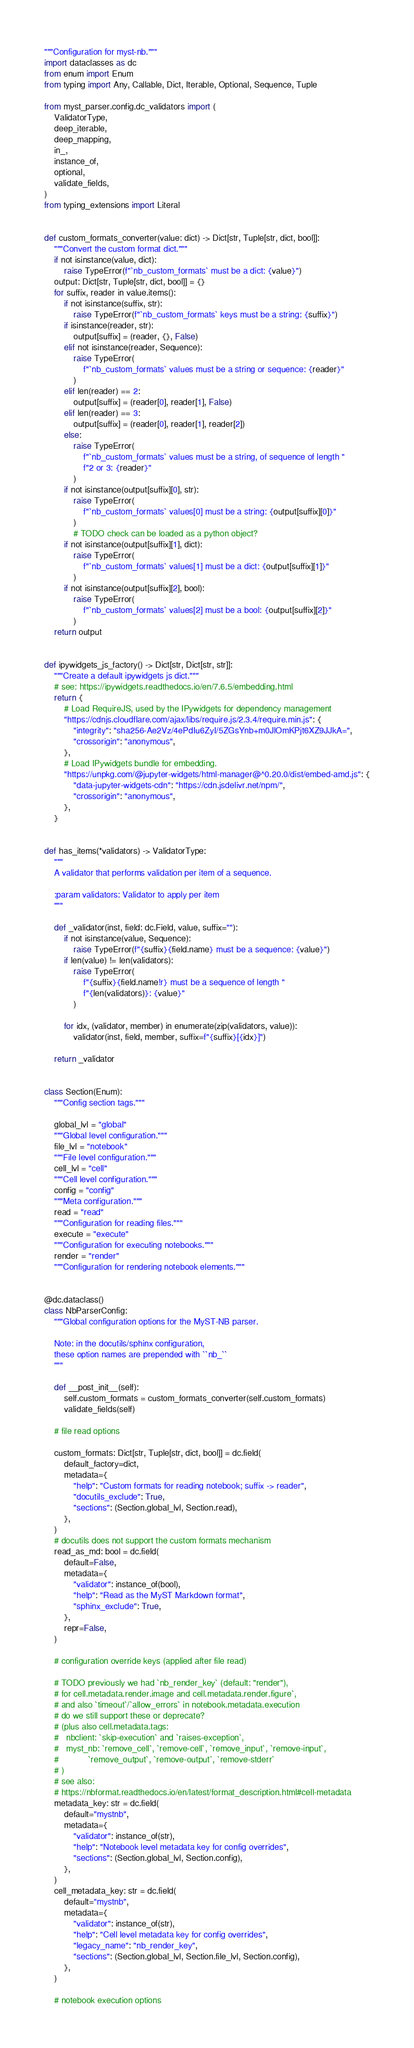Convert code to text. <code><loc_0><loc_0><loc_500><loc_500><_Python_>"""Configuration for myst-nb."""
import dataclasses as dc
from enum import Enum
from typing import Any, Callable, Dict, Iterable, Optional, Sequence, Tuple

from myst_parser.config.dc_validators import (
    ValidatorType,
    deep_iterable,
    deep_mapping,
    in_,
    instance_of,
    optional,
    validate_fields,
)
from typing_extensions import Literal


def custom_formats_converter(value: dict) -> Dict[str, Tuple[str, dict, bool]]:
    """Convert the custom format dict."""
    if not isinstance(value, dict):
        raise TypeError(f"`nb_custom_formats` must be a dict: {value}")
    output: Dict[str, Tuple[str, dict, bool]] = {}
    for suffix, reader in value.items():
        if not isinstance(suffix, str):
            raise TypeError(f"`nb_custom_formats` keys must be a string: {suffix}")
        if isinstance(reader, str):
            output[suffix] = (reader, {}, False)
        elif not isinstance(reader, Sequence):
            raise TypeError(
                f"`nb_custom_formats` values must be a string or sequence: {reader}"
            )
        elif len(reader) == 2:
            output[suffix] = (reader[0], reader[1], False)
        elif len(reader) == 3:
            output[suffix] = (reader[0], reader[1], reader[2])
        else:
            raise TypeError(
                f"`nb_custom_formats` values must be a string, of sequence of length "
                f"2 or 3: {reader}"
            )
        if not isinstance(output[suffix][0], str):
            raise TypeError(
                f"`nb_custom_formats` values[0] must be a string: {output[suffix][0]}"
            )
            # TODO check can be loaded as a python object?
        if not isinstance(output[suffix][1], dict):
            raise TypeError(
                f"`nb_custom_formats` values[1] must be a dict: {output[suffix][1]}"
            )
        if not isinstance(output[suffix][2], bool):
            raise TypeError(
                f"`nb_custom_formats` values[2] must be a bool: {output[suffix][2]}"
            )
    return output


def ipywidgets_js_factory() -> Dict[str, Dict[str, str]]:
    """Create a default ipywidgets js dict."""
    # see: https://ipywidgets.readthedocs.io/en/7.6.5/embedding.html
    return {
        # Load RequireJS, used by the IPywidgets for dependency management
        "https://cdnjs.cloudflare.com/ajax/libs/require.js/2.3.4/require.min.js": {
            "integrity": "sha256-Ae2Vz/4ePdIu6ZyI/5ZGsYnb+m0JlOmKPjt6XZ9JJkA=",
            "crossorigin": "anonymous",
        },
        # Load IPywidgets bundle for embedding.
        "https://unpkg.com/@jupyter-widgets/html-manager@^0.20.0/dist/embed-amd.js": {
            "data-jupyter-widgets-cdn": "https://cdn.jsdelivr.net/npm/",
            "crossorigin": "anonymous",
        },
    }


def has_items(*validators) -> ValidatorType:
    """
    A validator that performs validation per item of a sequence.

    :param validators: Validator to apply per item
    """

    def _validator(inst, field: dc.Field, value, suffix=""):
        if not isinstance(value, Sequence):
            raise TypeError(f"{suffix}{field.name} must be a sequence: {value}")
        if len(value) != len(validators):
            raise TypeError(
                f"{suffix}{field.name!r} must be a sequence of length "
                f"{len(validators)}: {value}"
            )

        for idx, (validator, member) in enumerate(zip(validators, value)):
            validator(inst, field, member, suffix=f"{suffix}[{idx}]")

    return _validator


class Section(Enum):
    """Config section tags."""

    global_lvl = "global"
    """Global level configuration."""
    file_lvl = "notebook"
    """File level configuration."""
    cell_lvl = "cell"
    """Cell level configuration."""
    config = "config"
    """Meta configuration."""
    read = "read"
    """Configuration for reading files."""
    execute = "execute"
    """Configuration for executing notebooks."""
    render = "render"
    """Configuration for rendering notebook elements."""


@dc.dataclass()
class NbParserConfig:
    """Global configuration options for the MyST-NB parser.

    Note: in the docutils/sphinx configuration,
    these option names are prepended with ``nb_``
    """

    def __post_init__(self):
        self.custom_formats = custom_formats_converter(self.custom_formats)
        validate_fields(self)

    # file read options

    custom_formats: Dict[str, Tuple[str, dict, bool]] = dc.field(
        default_factory=dict,
        metadata={
            "help": "Custom formats for reading notebook; suffix -> reader",
            "docutils_exclude": True,
            "sections": (Section.global_lvl, Section.read),
        },
    )
    # docutils does not support the custom formats mechanism
    read_as_md: bool = dc.field(
        default=False,
        metadata={
            "validator": instance_of(bool),
            "help": "Read as the MyST Markdown format",
            "sphinx_exclude": True,
        },
        repr=False,
    )

    # configuration override keys (applied after file read)

    # TODO previously we had `nb_render_key` (default: "render"),
    # for cell.metadata.render.image and cell.metadata.render.figure`,
    # and also `timeout`/`allow_errors` in notebook.metadata.execution
    # do we still support these or deprecate?
    # (plus also cell.metadata.tags:
    #   nbclient: `skip-execution` and `raises-exception`,
    #   myst_nb: `remove_cell`, `remove-cell`, `remove_input`, `remove-input`,
    #            `remove_output`, `remove-output`, `remove-stderr`
    # )
    # see also:
    # https://nbformat.readthedocs.io/en/latest/format_description.html#cell-metadata
    metadata_key: str = dc.field(
        default="mystnb",
        metadata={
            "validator": instance_of(str),
            "help": "Notebook level metadata key for config overrides",
            "sections": (Section.global_lvl, Section.config),
        },
    )
    cell_metadata_key: str = dc.field(
        default="mystnb",
        metadata={
            "validator": instance_of(str),
            "help": "Cell level metadata key for config overrides",
            "legacy_name": "nb_render_key",
            "sections": (Section.global_lvl, Section.file_lvl, Section.config),
        },
    )

    # notebook execution options
</code> 